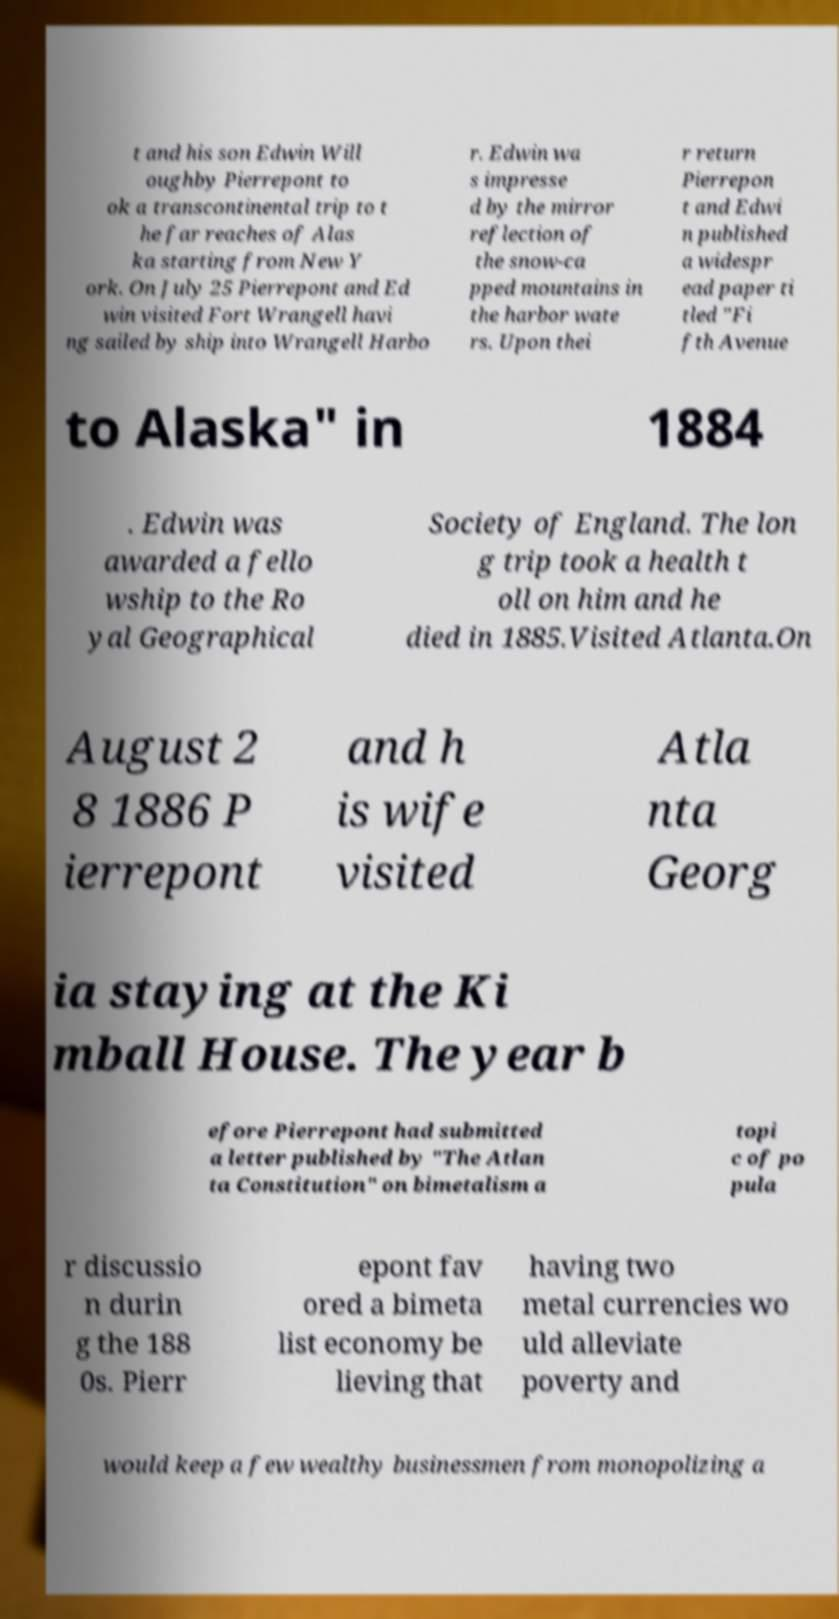There's text embedded in this image that I need extracted. Can you transcribe it verbatim? t and his son Edwin Will oughby Pierrepont to ok a transcontinental trip to t he far reaches of Alas ka starting from New Y ork. On July 25 Pierrepont and Ed win visited Fort Wrangell havi ng sailed by ship into Wrangell Harbo r. Edwin wa s impresse d by the mirror reflection of the snow-ca pped mountains in the harbor wate rs. Upon thei r return Pierrepon t and Edwi n published a widespr ead paper ti tled "Fi fth Avenue to Alaska" in 1884 . Edwin was awarded a fello wship to the Ro yal Geographical Society of England. The lon g trip took a health t oll on him and he died in 1885.Visited Atlanta.On August 2 8 1886 P ierrepont and h is wife visited Atla nta Georg ia staying at the Ki mball House. The year b efore Pierrepont had submitted a letter published by "The Atlan ta Constitution" on bimetalism a topi c of po pula r discussio n durin g the 188 0s. Pierr epont fav ored a bimeta list economy be lieving that having two metal currencies wo uld alleviate poverty and would keep a few wealthy businessmen from monopolizing a 